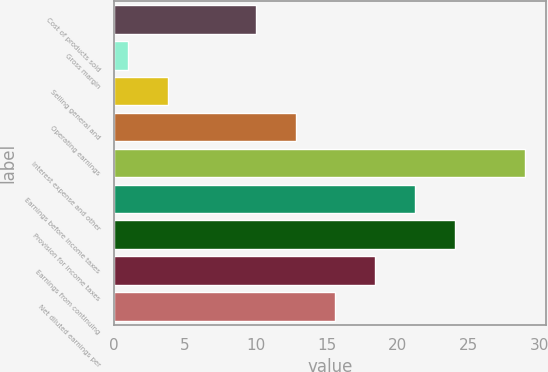Convert chart to OTSL. <chart><loc_0><loc_0><loc_500><loc_500><bar_chart><fcel>Cost of products sold<fcel>Gross margin<fcel>Selling general and<fcel>Operating earnings<fcel>Interest expense and other<fcel>Earnings before income taxes<fcel>Provision for income taxes<fcel>Earnings from continuing<fcel>Net diluted earnings per<nl><fcel>10<fcel>1<fcel>3.8<fcel>12.8<fcel>29<fcel>21.2<fcel>24<fcel>18.4<fcel>15.6<nl></chart> 